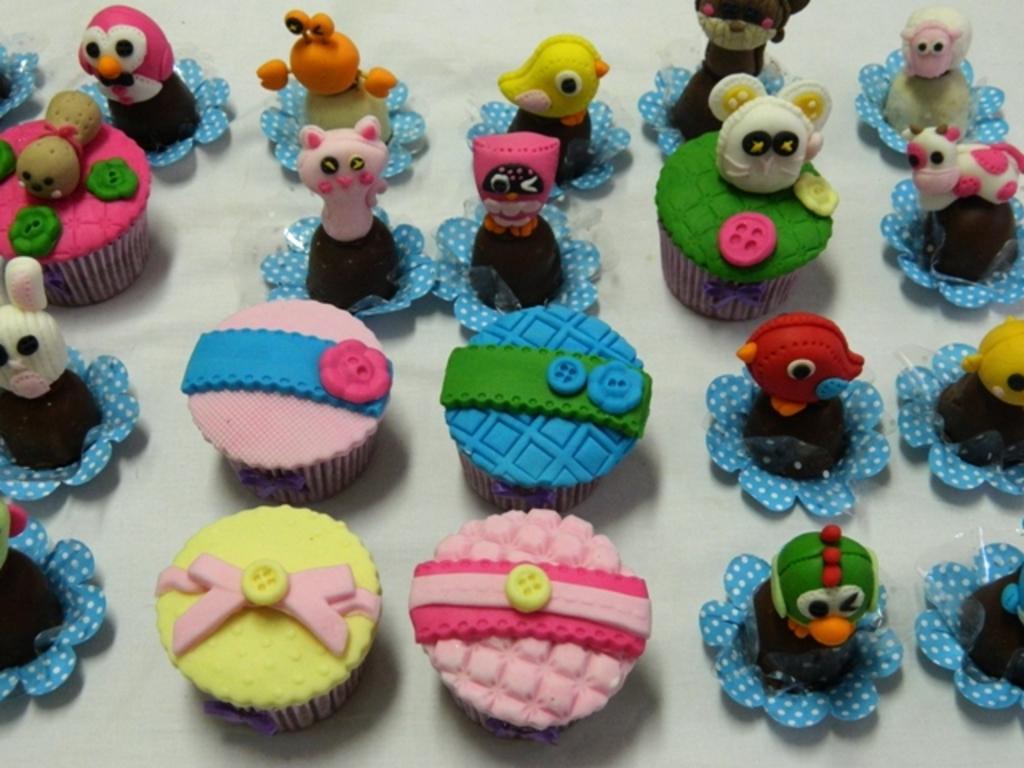How would you summarize this image in a sentence or two? In this image I can see few cupcakes and few toys on the white color surface and the cupcakes and toys are in multi color. 